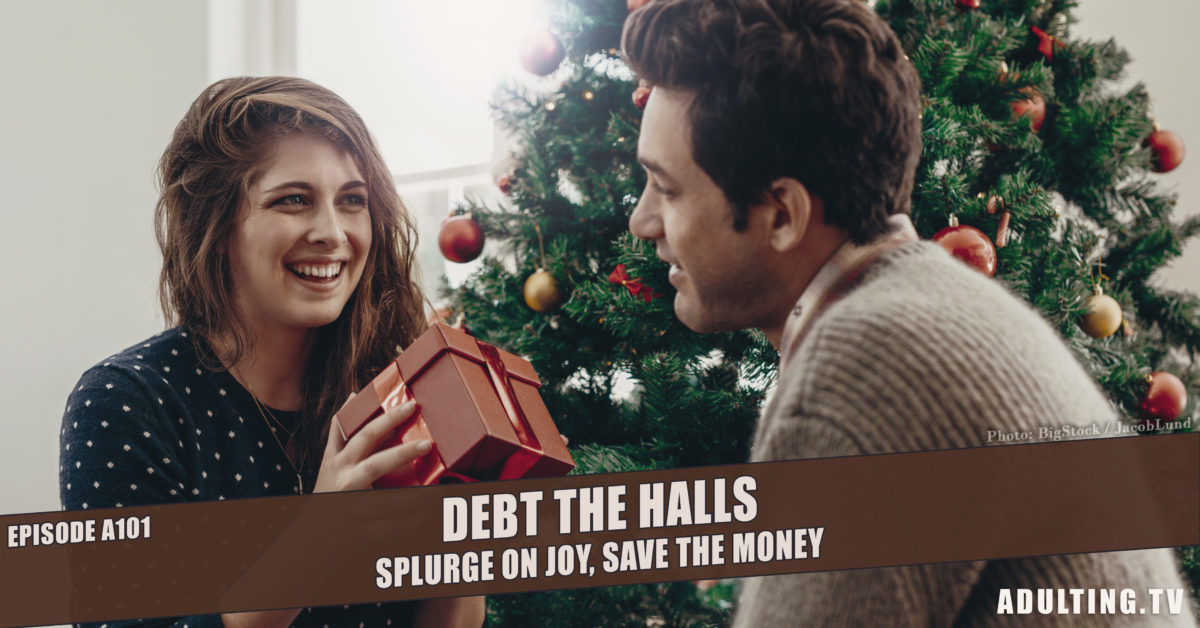What are the people in the image likely celebrating? The people in the image are likely celebrating a holiday occasion, evidenced by the Christmas tree and decorations, suggesting a festive Christmas gathering. They seem to be sharing gifts, which is a common tradition during the Christmas holiday, celebrating togetherness and the spirit of giving. 